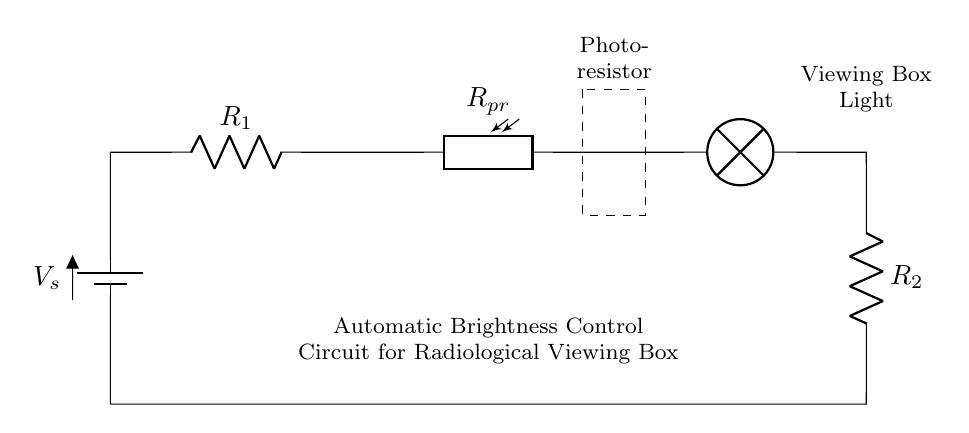What is the type of this circuit? The circuit is a series circuit because all components are connected end-to-end in a single path for the current to flow.
Answer: Series circuit What component controls the brightness? The photoresistor controls the brightness. Its resistance changes with light exposure, affecting the current flowing through the circuit.
Answer: Photoresistor What is the purpose of the resistor labeled R1? R1 is used to limit the current flowing through the circuit, protecting the other components from excessive current.
Answer: Current limiting How many resistors are in the circuit diagram? There are two resistors shown in the circuit diagram: R1 and R2.
Answer: Two What happens to the lamp's brightness as light increases? As light increases, the resistance of the photoresistor decreases, allowing more current to flow, which increases the brightness of the lamp.
Answer: Increases What will happen to the circuit if the photoresistor is completely dark? If the photoresistor is completely dark, its resistance will be high, leading to reduced current flow and causing the lamp to dim or turn off.
Answer: Dims or turns off What is indicated by the dashed rectangle around the photoresistor? The dashed rectangle indicates a specific component in the circuit, highlighting it as the photoresistor whose characteristics directly impact circuit functionality.
Answer: Photoresistor 